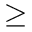<formula> <loc_0><loc_0><loc_500><loc_500>\geq</formula> 